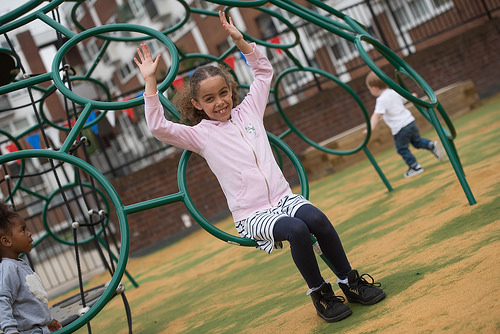<image>
Is the shoe on the ground? Yes. Looking at the image, I can see the shoe is positioned on top of the ground, with the ground providing support. 